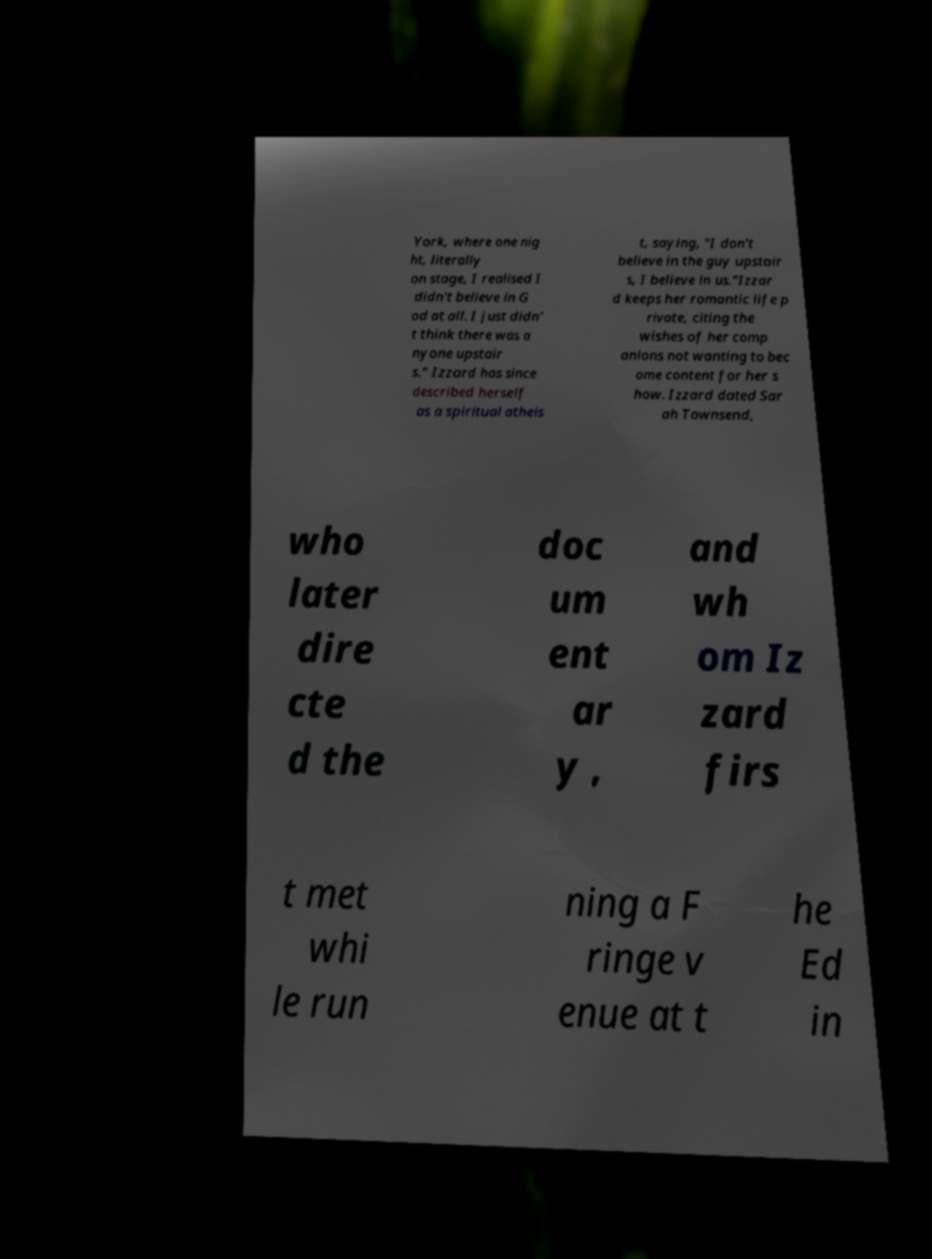Could you extract and type out the text from this image? York, where one nig ht, literally on stage, I realised I didn't believe in G od at all. I just didn' t think there was a nyone upstair s." Izzard has since described herself as a spiritual atheis t, saying, "I don't believe in the guy upstair s, I believe in us."Izzar d keeps her romantic life p rivate, citing the wishes of her comp anions not wanting to bec ome content for her s how. Izzard dated Sar ah Townsend, who later dire cte d the doc um ent ar y , and wh om Iz zard firs t met whi le run ning a F ringe v enue at t he Ed in 